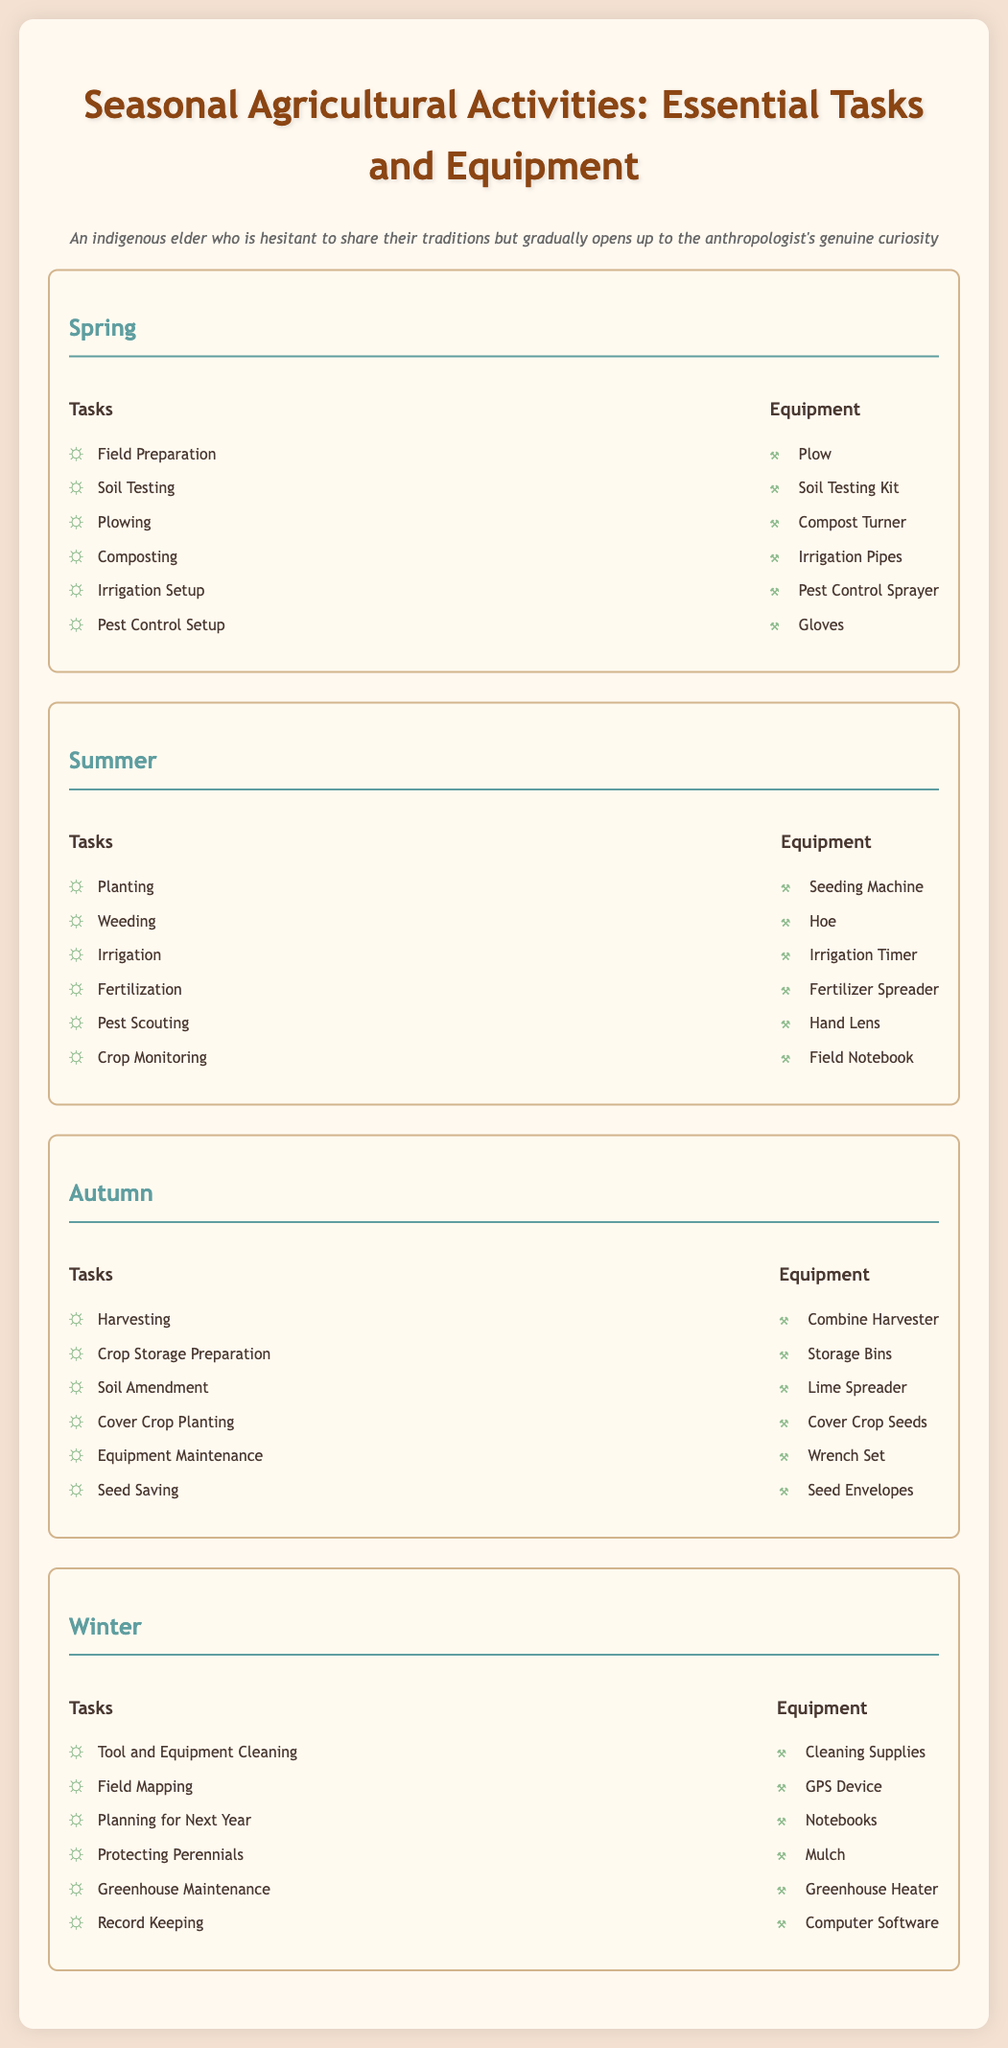What are the tasks in Spring? The list of tasks for Spring is provided in the document under that section.
Answer: Field Preparation, Soil Testing, Plowing, Composting, Irrigation Setup, Pest Control Setup Which equipment is used for harvesting? The document specifies the equipment associated with harvesting in the Autumn section.
Answer: Combine Harvester How many tasks are listed for Winter? The document enumerates the tasks for Winter in that section, and by counting them, we find the number.
Answer: Six What is the first task listed for Summer? The first task in the Summer section provides the answer directly.
Answer: Planting Which season includes Soil Testing as a task? The task of Soil Testing is found within the tasks listed under Spring.
Answer: Spring What equipment is mentioned for irrigation in Summer? The equipment listed specifically for irrigation in the Summer section provides the answer.
Answer: Irrigation Timer How many pieces of equipment are listed for Autumn? The equipment mentioned in the Autumn section must be counted to get the answer.
Answer: Six Which task involves "record keeping"? The specific task of record keeping is mentioned in the Winter section, indicating its categorization.
Answer: Record Keeping 